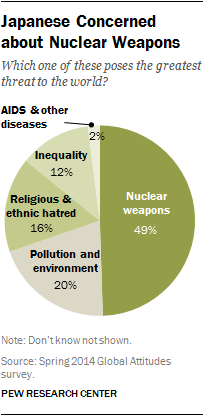Give some essential details in this illustration. The ratio of the smallest and second largest segments is 0.048611111... The biggest segment is 49%. 